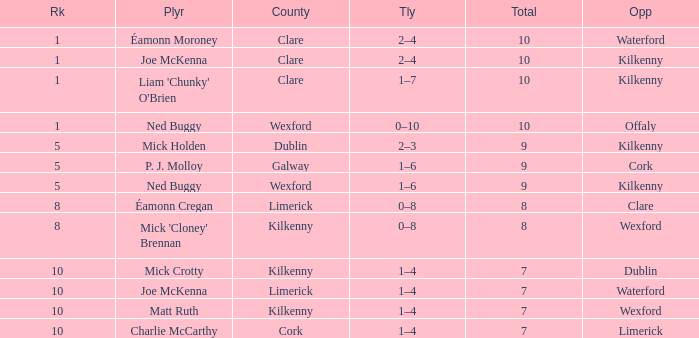Which County has a Rank larger than 8, and a Player of joe mckenna? Limerick. 